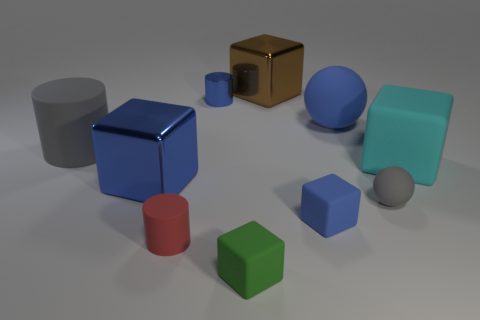Subtract all purple balls. How many blue cubes are left? 2 Subtract all big brown metal blocks. How many blocks are left? 4 Subtract all green blocks. How many blocks are left? 4 Subtract 2 cubes. How many cubes are left? 3 Subtract all spheres. How many objects are left? 8 Subtract all gray cubes. Subtract all brown spheres. How many cubes are left? 5 Add 7 large blue spheres. How many large blue spheres exist? 8 Subtract 0 yellow spheres. How many objects are left? 10 Subtract all tiny blue shiny objects. Subtract all cylinders. How many objects are left? 6 Add 3 big shiny things. How many big shiny things are left? 5 